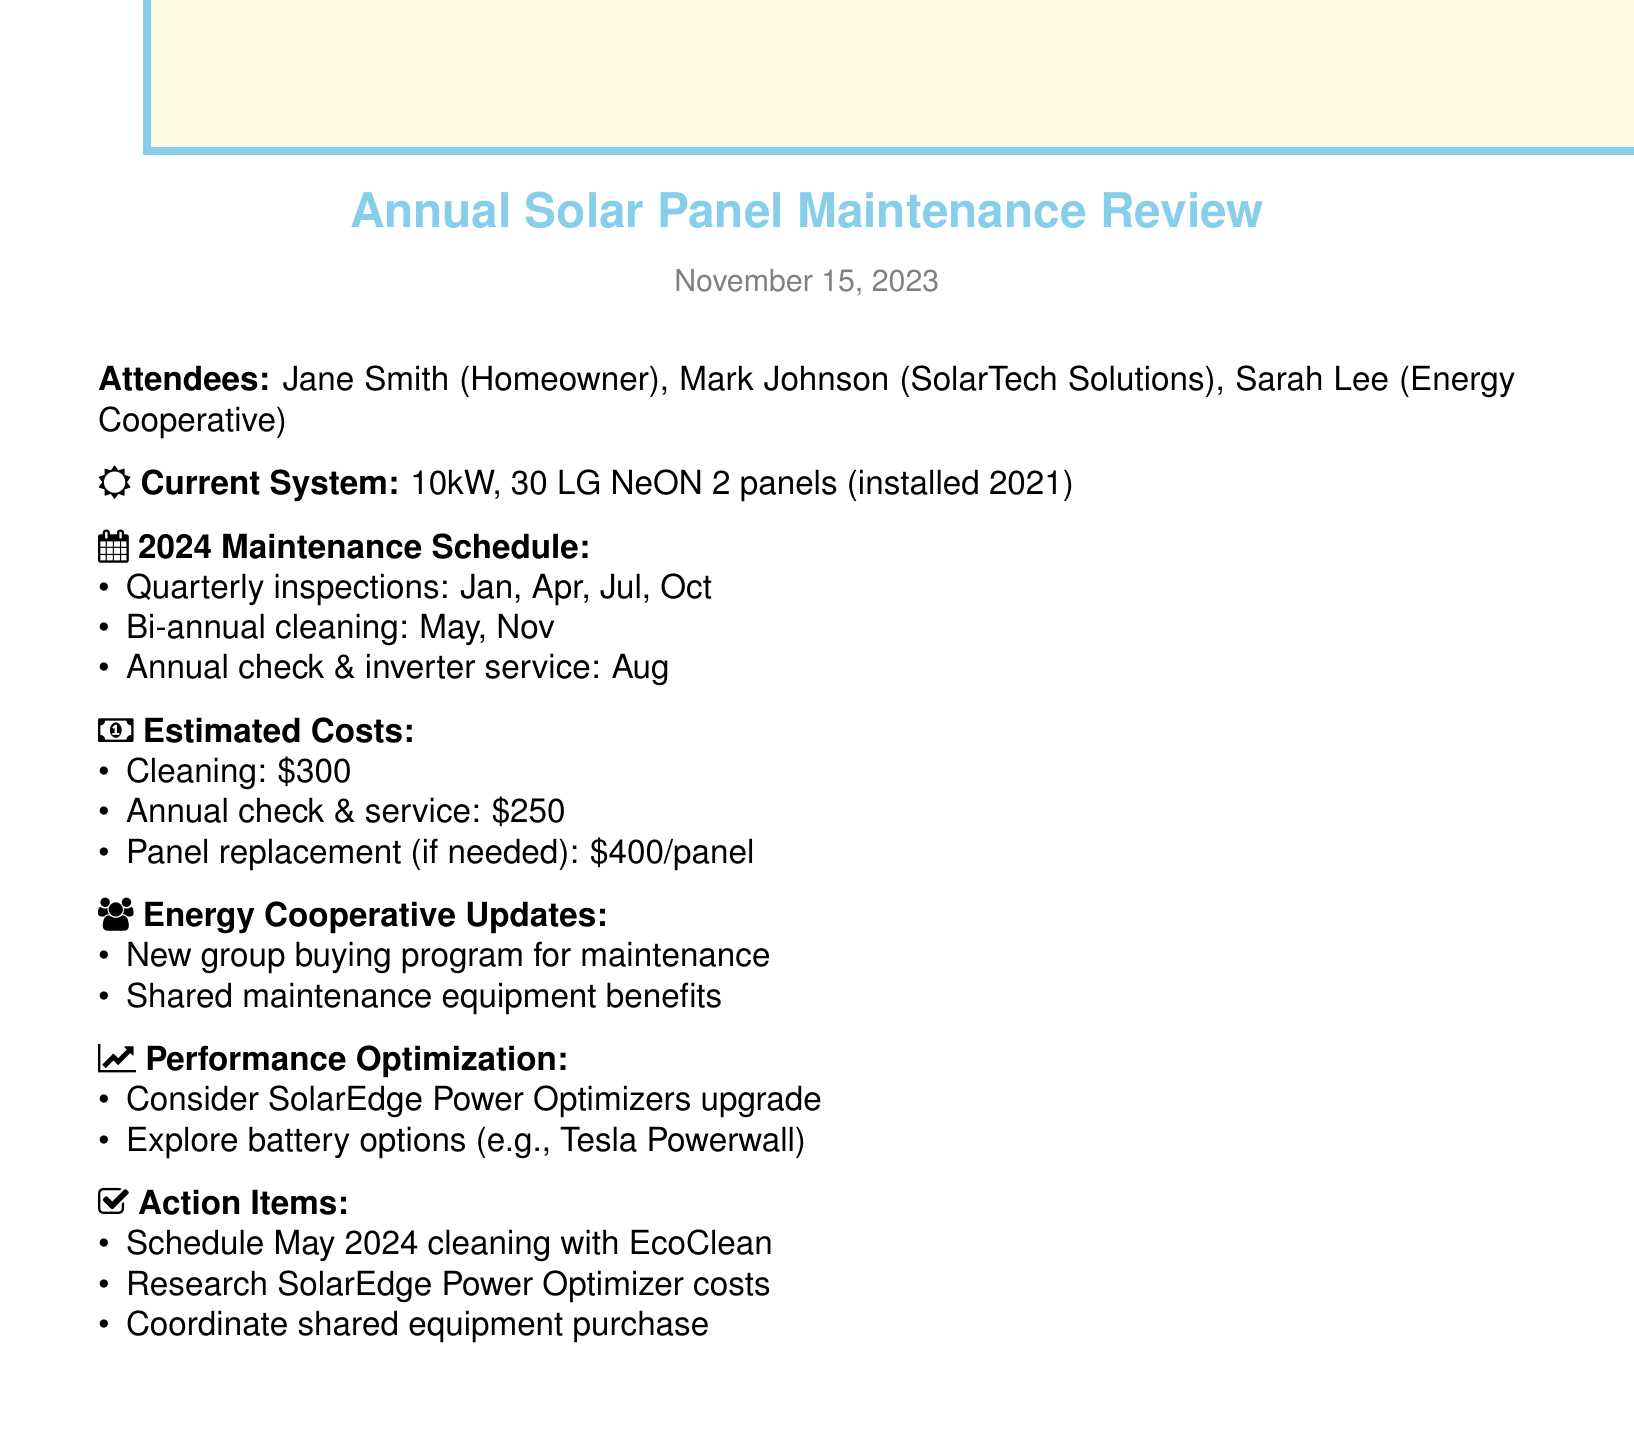what is the date of the meeting? The date of the meeting is mentioned in the document as November 15, 2023.
Answer: November 15, 2023 who are the attendees of the meeting? The document lists three attendees.
Answer: Jane Smith, Mark Johnson, Sarah Lee how many panels are in the current solar panel system? The document specifies that there are 30 panels installed in the solar panel system.
Answer: 30 what is the cost of the annual performance check? The estimated maintenance costs include $250 for the annual performance check as mentioned in the costs breakdown.
Answer: $250 how often are visual inspections scheduled? The maintenance schedule states that visual inspections are scheduled quarterly, which means four times a year.
Answer: Quarterly what type of upgrade is suggested for performance optimization? The document suggests considering an upgrade to SolarEdge Power Optimizers as part of performance optimization.
Answer: SolarEdge Power Optimizers when is the bi-annual cleaning scheduled? The document specifies that the bi-annual cleaning is scheduled for May and November.
Answer: May, November what action item involves EcoClean Services? The action items list a schedule for cleaning in May 2024 with EcoClean Services.
Answer: Schedule May 2024 cleaning with EcoClean what is the estimated cost for panel replacement if needed? The document mentions a potential cost for panel replacement at $400 per panel if needed.
Answer: $400 per panel 